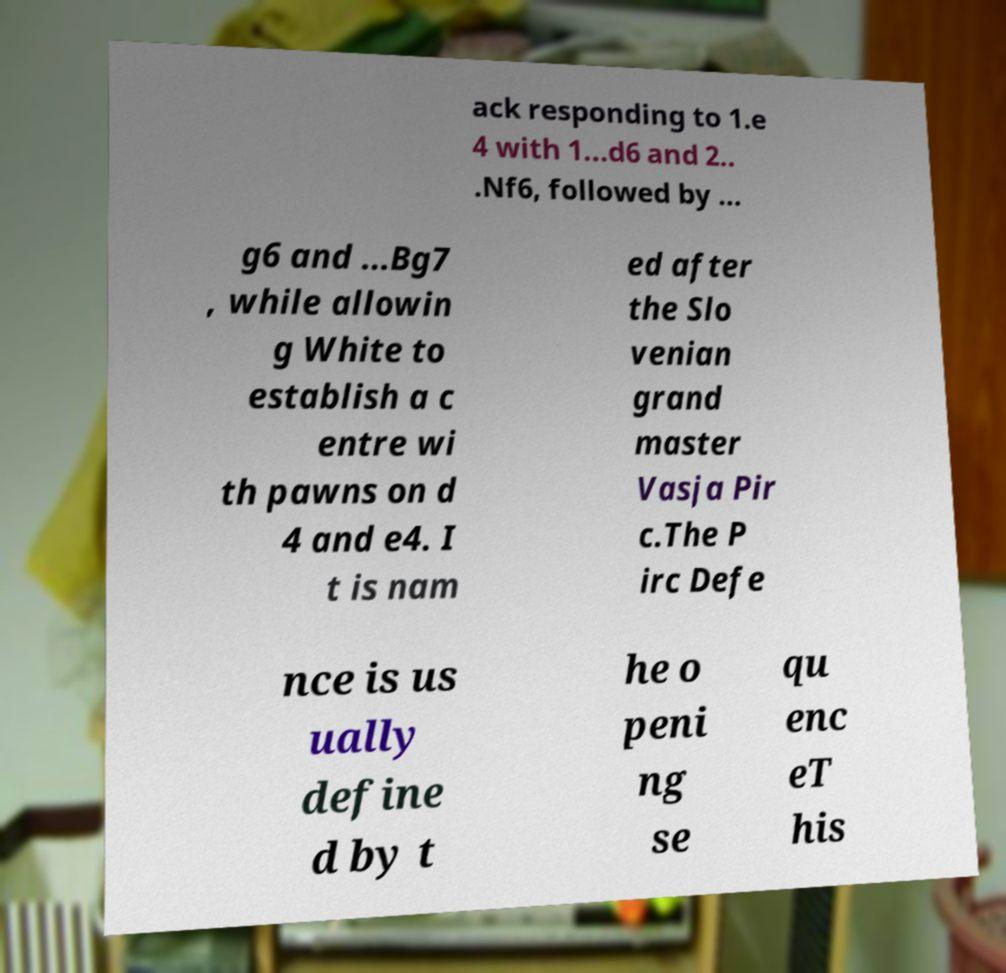Could you assist in decoding the text presented in this image and type it out clearly? ack responding to 1.e 4 with 1...d6 and 2.. .Nf6, followed by ... g6 and ...Bg7 , while allowin g White to establish a c entre wi th pawns on d 4 and e4. I t is nam ed after the Slo venian grand master Vasja Pir c.The P irc Defe nce is us ually define d by t he o peni ng se qu enc eT his 